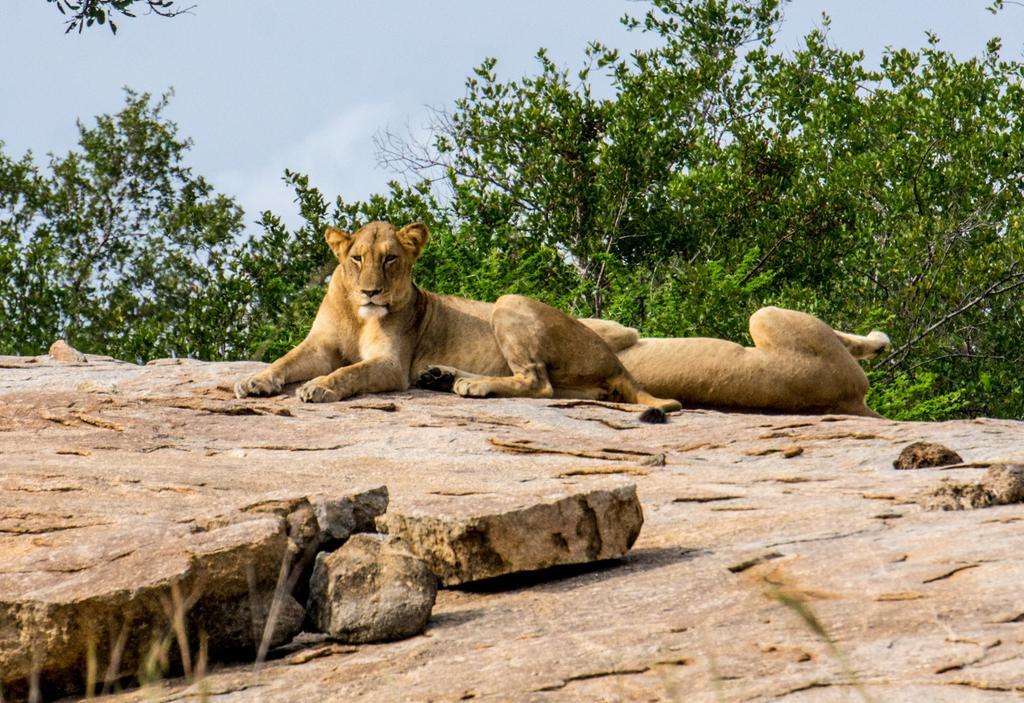Describe this image in one or two sentences. In the image we can see there are two lioness sitting on the surface of the rock and behind there are trees. 